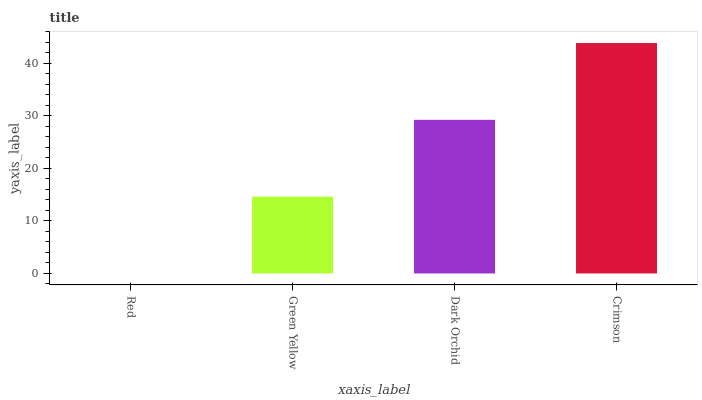Is Red the minimum?
Answer yes or no. Yes. Is Crimson the maximum?
Answer yes or no. Yes. Is Green Yellow the minimum?
Answer yes or no. No. Is Green Yellow the maximum?
Answer yes or no. No. Is Green Yellow greater than Red?
Answer yes or no. Yes. Is Red less than Green Yellow?
Answer yes or no. Yes. Is Red greater than Green Yellow?
Answer yes or no. No. Is Green Yellow less than Red?
Answer yes or no. No. Is Dark Orchid the high median?
Answer yes or no. Yes. Is Green Yellow the low median?
Answer yes or no. Yes. Is Red the high median?
Answer yes or no. No. Is Red the low median?
Answer yes or no. No. 